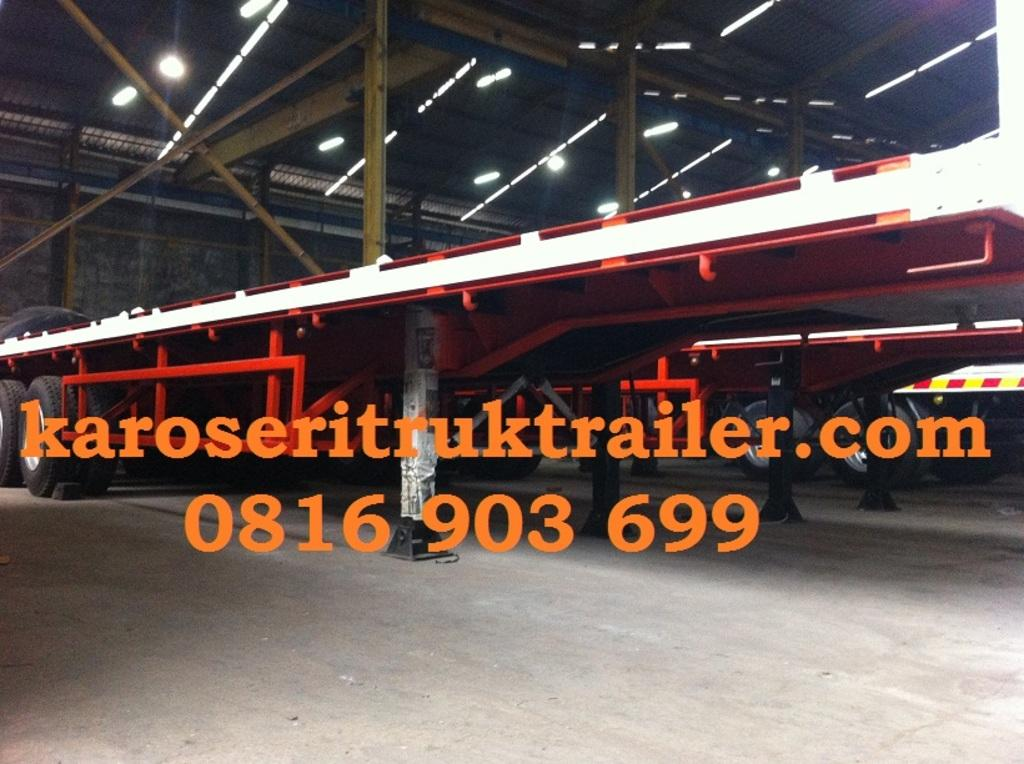What types of objects can be seen in the image? There are vehicles in the image. What can be seen beneath the vehicles? The ground is visible in the image. What are the vertical structures in the image? There are poles in the image. What are the poles supporting? There are lights in the image, which are supported by the poles. What is the background of the image made of? There is a wall in the image, which forms the background. What is covering the top of the scene? There is a roof in the image, which covers the top of the scene. Is there any text or writing present in the image? Yes, something is written on one of these elements in the image. How much does the snow weigh in the image? There is no snow present in the image. What type of frame is holding the dime in the image? There is no dime or frame present in the image. 